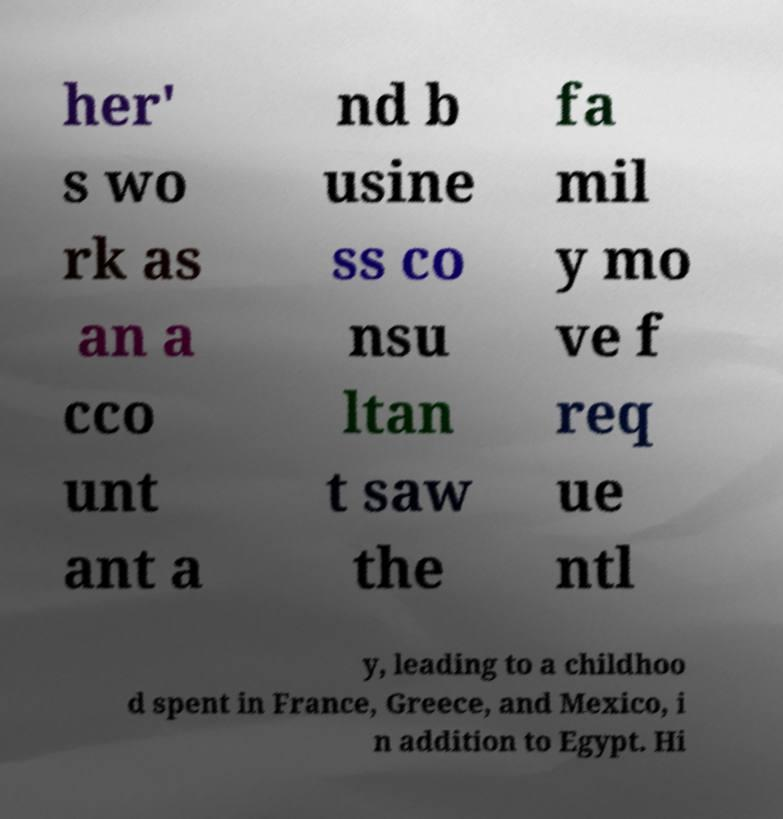For documentation purposes, I need the text within this image transcribed. Could you provide that? her' s wo rk as an a cco unt ant a nd b usine ss co nsu ltan t saw the fa mil y mo ve f req ue ntl y, leading to a childhoo d spent in France, Greece, and Mexico, i n addition to Egypt. Hi 